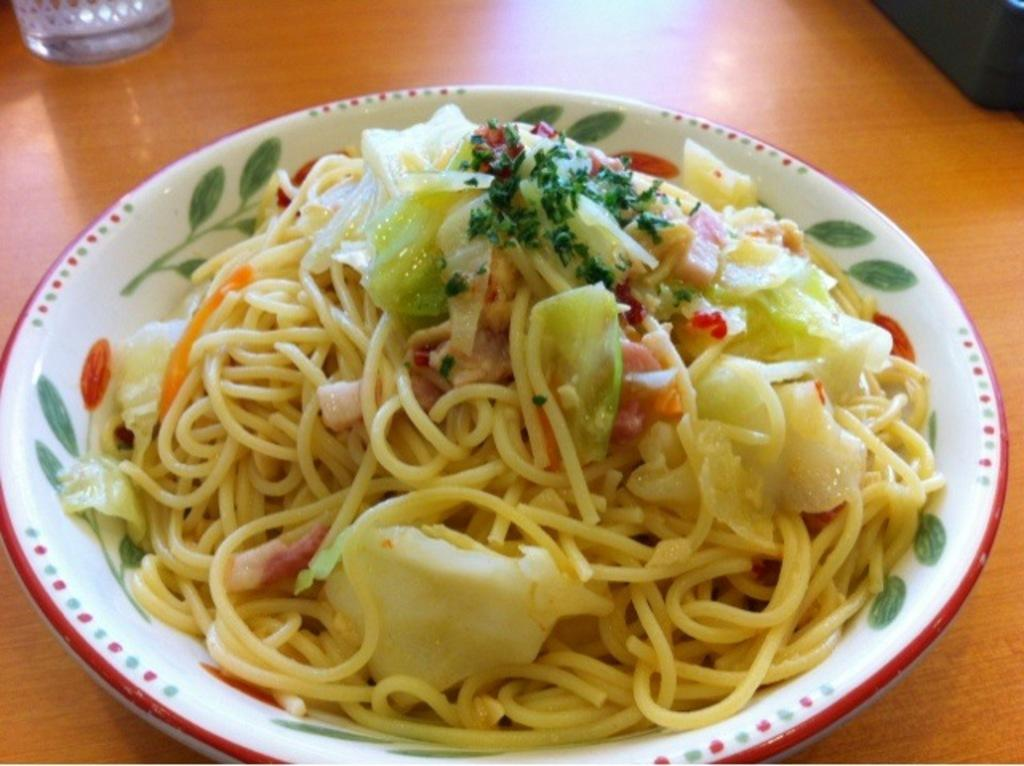What is on the table in the image? There is a plate and a glass on the table in the image. What is on the plate? The plate contains noodles and other ingredients. Can you describe the glass on the table? The glass is on the table, but its contents are not specified. What is at the back of the table? There is an unspecified object at the back of the table. What type of arch can be seen in the image? There is no arch present in the image. Is there a rat hiding under the plate in the image? There is no rat present in the image. 